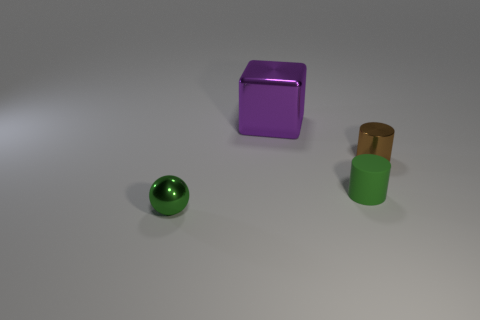Add 4 matte objects. How many objects exist? 8 Subtract all spheres. How many objects are left? 3 Add 2 tiny green metallic objects. How many tiny green metallic objects are left? 3 Add 3 small shiny cylinders. How many small shiny cylinders exist? 4 Subtract 0 cyan spheres. How many objects are left? 4 Subtract all purple metal cylinders. Subtract all green metallic spheres. How many objects are left? 3 